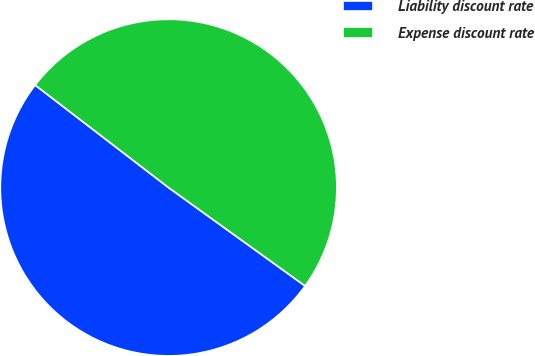Convert chart to OTSL. <chart><loc_0><loc_0><loc_500><loc_500><pie_chart><fcel>Liability discount rate<fcel>Expense discount rate<nl><fcel>50.49%<fcel>49.51%<nl></chart> 